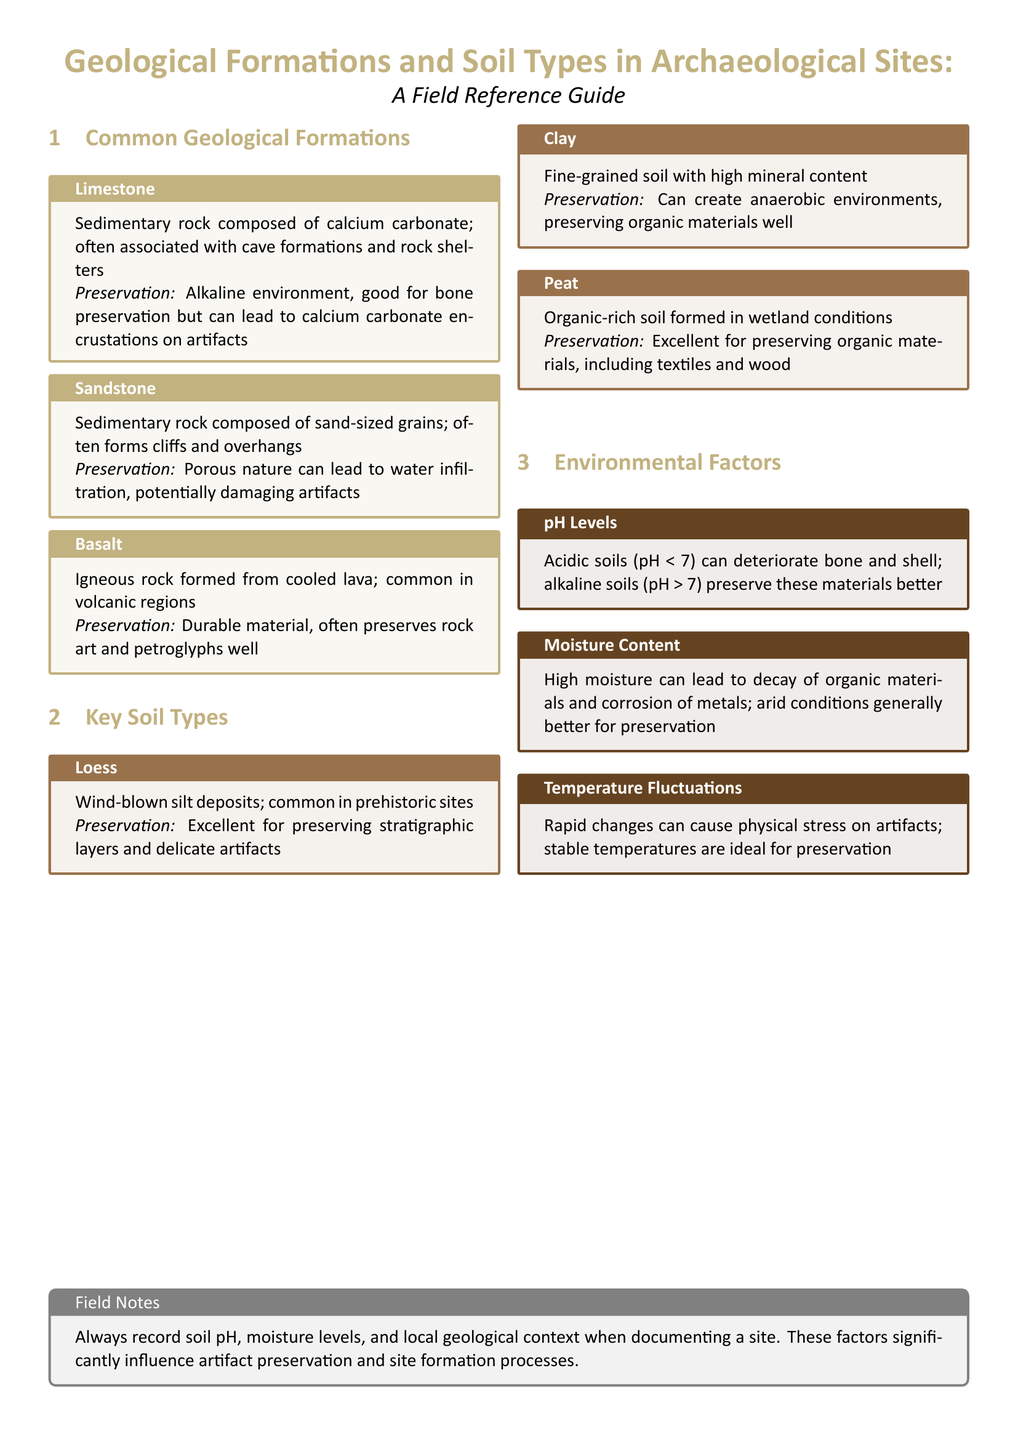What is the composition of limestone? Limestone is described as a sedimentary rock composed of calcium carbonate.
Answer: calcium carbonate What type of rock is basalt? Basalt is identified as an igneous rock formed from cooled lava.
Answer: igneous What is the preservation quality of loess? Loess is noted for its excellent ability to preserve stratigraphic layers and delicate artifacts.
Answer: Excellent How does pH level affect preservation? The document states that acidic soils can deteriorate bone and shell while alkaline soils preserve these materials better.
Answer: Deteriorate and preserve What are the effects of high moisture on organic materials? High moisture is reported to lead to decay of organic materials and corrosion of metals.
Answer: Decay and corrosion Which soil type is formed in wetland conditions? The document describes peat as being formed in wetland conditions.
Answer: Peat What should always be recorded when documenting a site? The field notes advise to always record soil pH, moisture levels, and local geological context.
Answer: Soil pH, moisture levels, local geological context What type of geological formation is sandstone? Sandstone is classified as a sedimentary rock composed of sand-sized grains.
Answer: Sedimentary What is a major characteristic of clay soil? Clay is characterized as fine-grained soil with high mineral content.
Answer: Fine-grained, high mineral content 